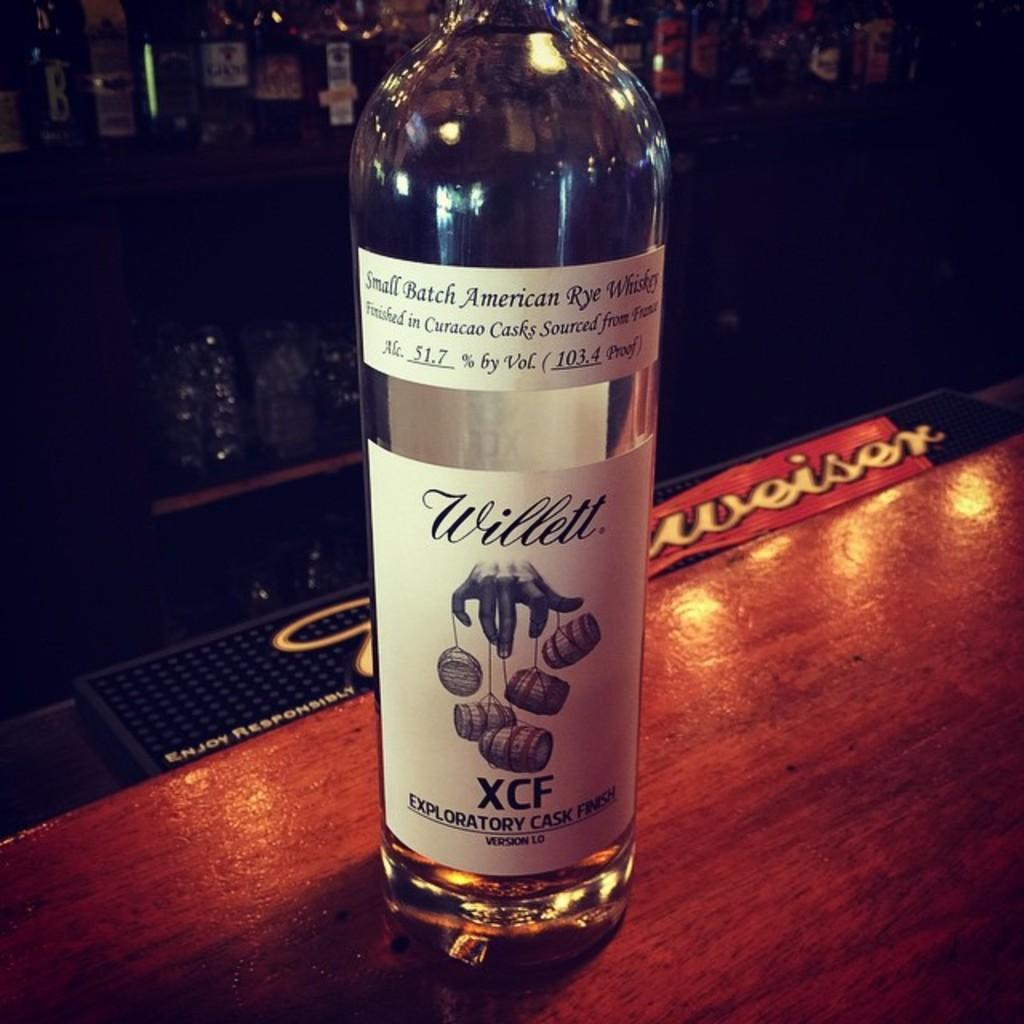<image>
Share a concise interpretation of the image provided. A bottle on a table has the letters XCF on the label. 